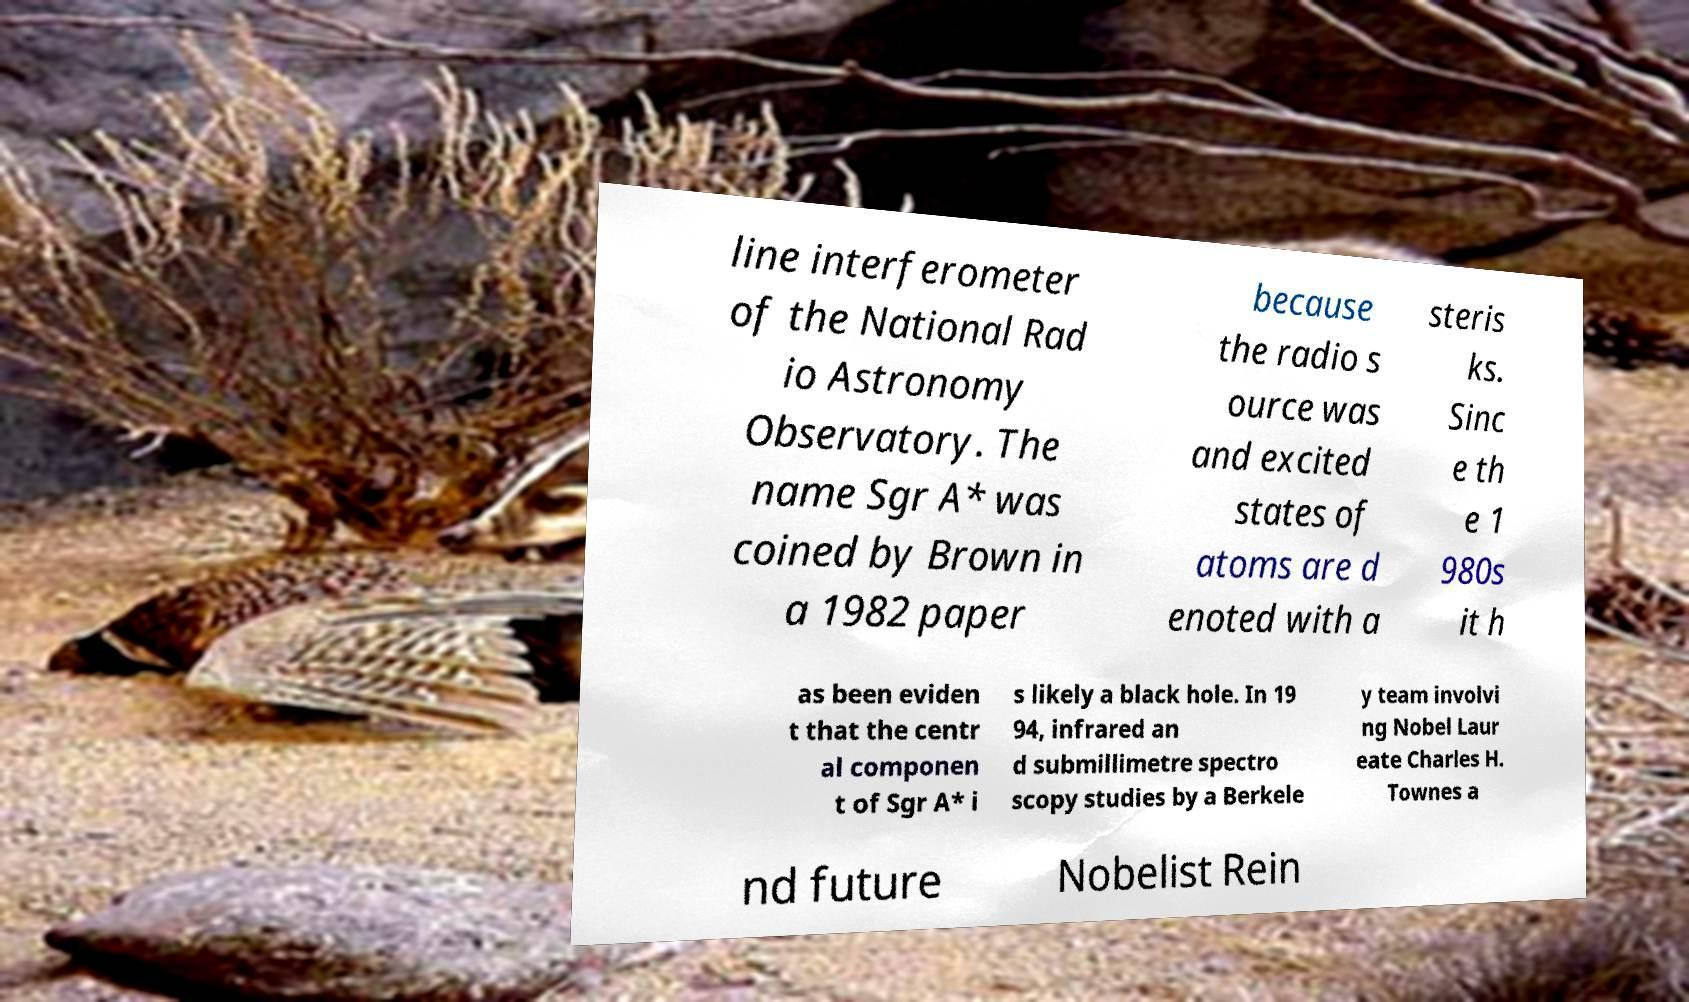Please read and relay the text visible in this image. What does it say? line interferometer of the National Rad io Astronomy Observatory. The name Sgr A* was coined by Brown in a 1982 paper because the radio s ource was and excited states of atoms are d enoted with a steris ks. Sinc e th e 1 980s it h as been eviden t that the centr al componen t of Sgr A* i s likely a black hole. In 19 94, infrared an d submillimetre spectro scopy studies by a Berkele y team involvi ng Nobel Laur eate Charles H. Townes a nd future Nobelist Rein 